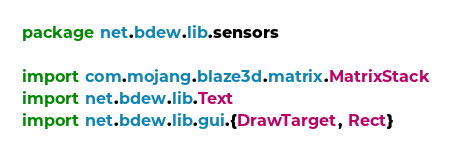<code> <loc_0><loc_0><loc_500><loc_500><_Scala_>package net.bdew.lib.sensors

import com.mojang.blaze3d.matrix.MatrixStack
import net.bdew.lib.Text
import net.bdew.lib.gui.{DrawTarget, Rect}</code> 